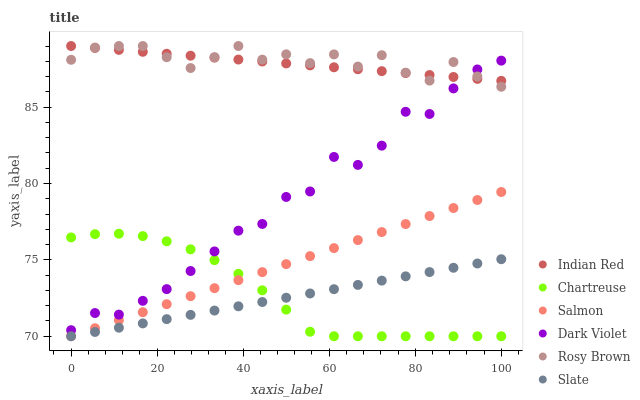Does Slate have the minimum area under the curve?
Answer yes or no. Yes. Does Rosy Brown have the maximum area under the curve?
Answer yes or no. Yes. Does Salmon have the minimum area under the curve?
Answer yes or no. No. Does Salmon have the maximum area under the curve?
Answer yes or no. No. Is Slate the smoothest?
Answer yes or no. Yes. Is Dark Violet the roughest?
Answer yes or no. Yes. Is Rosy Brown the smoothest?
Answer yes or no. No. Is Rosy Brown the roughest?
Answer yes or no. No. Does Slate have the lowest value?
Answer yes or no. Yes. Does Rosy Brown have the lowest value?
Answer yes or no. No. Does Indian Red have the highest value?
Answer yes or no. Yes. Does Salmon have the highest value?
Answer yes or no. No. Is Salmon less than Rosy Brown?
Answer yes or no. Yes. Is Dark Violet greater than Slate?
Answer yes or no. Yes. Does Rosy Brown intersect Indian Red?
Answer yes or no. Yes. Is Rosy Brown less than Indian Red?
Answer yes or no. No. Is Rosy Brown greater than Indian Red?
Answer yes or no. No. Does Salmon intersect Rosy Brown?
Answer yes or no. No. 